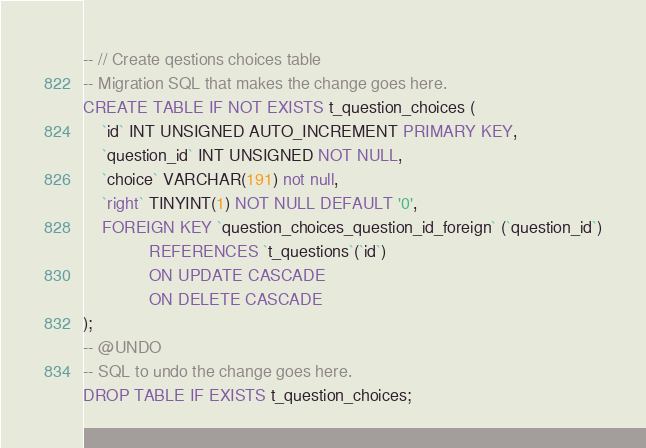<code> <loc_0><loc_0><loc_500><loc_500><_SQL_>-- // Create qestions choices table
-- Migration SQL that makes the change goes here.
CREATE TABLE IF NOT EXISTS t_question_choices (
    `id` INT UNSIGNED AUTO_INCREMENT PRIMARY KEY,
    `question_id` INT UNSIGNED NOT NULL,
    `choice` VARCHAR(191) not null,
    `right` TINYINT(1) NOT NULL DEFAULT '0',
    FOREIGN KEY `question_choices_question_id_foreign` (`question_id`)
              REFERENCES `t_questions`(`id`)
              ON UPDATE CASCADE
              ON DELETE CASCADE
);
-- @UNDO
-- SQL to undo the change goes here.
DROP TABLE IF EXISTS t_question_choices;
</code> 